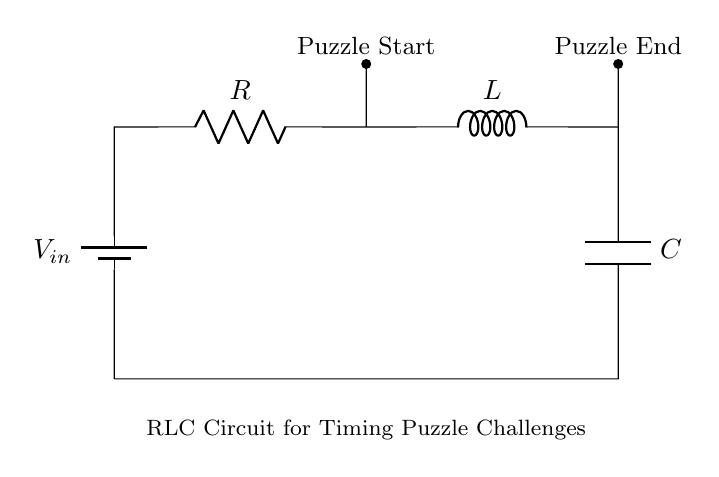What is the input voltage of the circuit? The input voltage can be identified at the battery symbol in the circuit diagram, labeled as \(V_{in}\). It represents the voltage source connected to the circuit, but the actual value is not specified in the visual.
Answer: \(V_{in}\) What components are present in this circuit? The circuit consists of three primary components: a resistor, an inductor, and a capacitor. These components are clearly labeled in the diagram and are arranged in series.
Answer: Resistor, Inductor, Capacitor Which way does current flow in the circuit? Current flows from the positive terminal of the battery, through the resistor, inductor, and capacitor, returning to the negative terminal of the battery. This is a typical flow direction in series circuits.
Answer: Clockwise What is the role of the inductor in this circuit? The inductor is used to store energy in a magnetic field and introduces a phase shift in current and voltage. It also impacts the timing characteristics of the circuit, which is essential for escape room puzzles.
Answer: Energy storage What happens to the circuit if the value of the resistance increases significantly? Increasing resistance will reduce the overall current in the circuit according to Ohm's Law. This will affect the timing of how fast the circuit can respond, impacting the puzzle-solving mechanism. Higher resistance leads to longer timing intervals.
Answer: Slower timing How does the capacitance affect the timing in this RLC circuit? Capacitance affects the charge and discharge cycles in the circuit. A higher capacitance allows the capacitor to store more charge, which can extend the time taken for the circuit to complete a cycle. This is critical for puzzle timing, affecting how long a challenge might last.
Answer: Longer timing What is the significance of the nodes labeled "Puzzle Start" and "Puzzle End"? These nodes indicate the beginning and completion points of the timing challenge in the escape room. The duration between these two points helps determine the success or failure of completing the puzzle based on timing.
Answer: Timing challenge indicators 